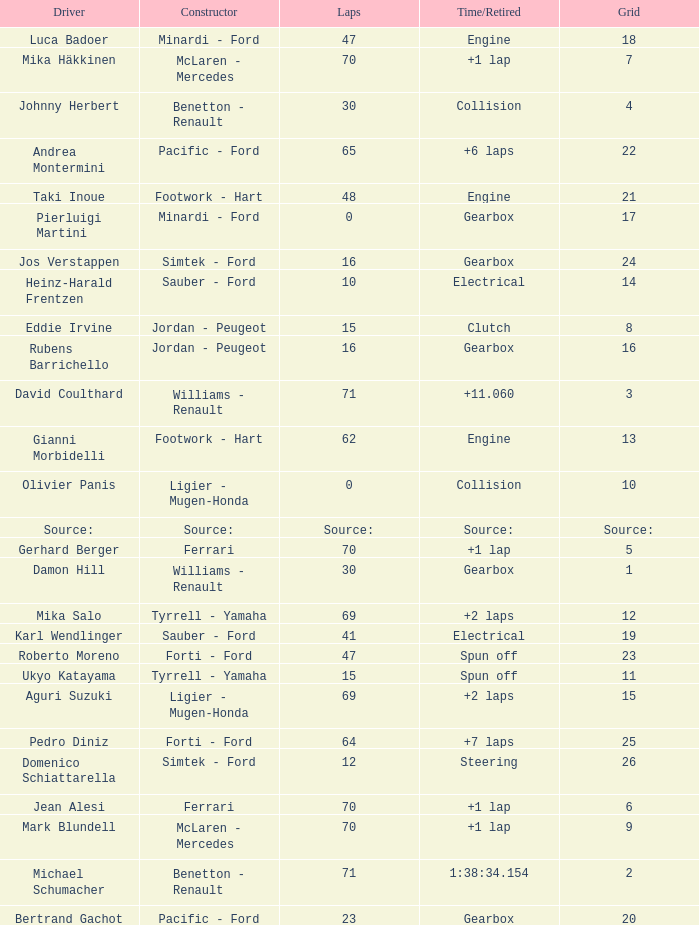David Coulthard was the driver in which grid? 3.0. 